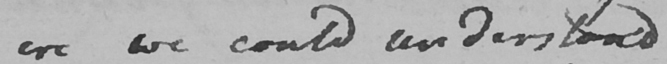What is written in this line of handwriting? ere we could understand 